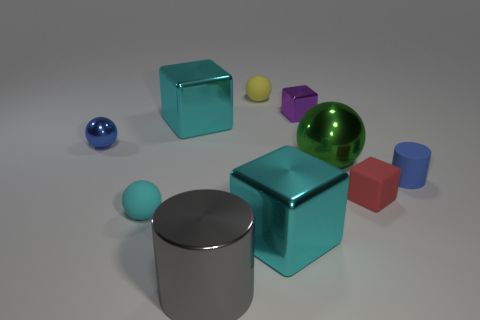Subtract all brown cylinders. How many cyan blocks are left? 2 Subtract 1 balls. How many balls are left? 3 Subtract all yellow rubber balls. How many balls are left? 3 Subtract all cyan spheres. How many spheres are left? 3 Subtract all spheres. How many objects are left? 6 Subtract all yellow blocks. Subtract all red balls. How many blocks are left? 4 Subtract 0 green cubes. How many objects are left? 10 Subtract all small cylinders. Subtract all red rubber things. How many objects are left? 8 Add 2 blue cylinders. How many blue cylinders are left? 3 Add 3 tiny blue cylinders. How many tiny blue cylinders exist? 4 